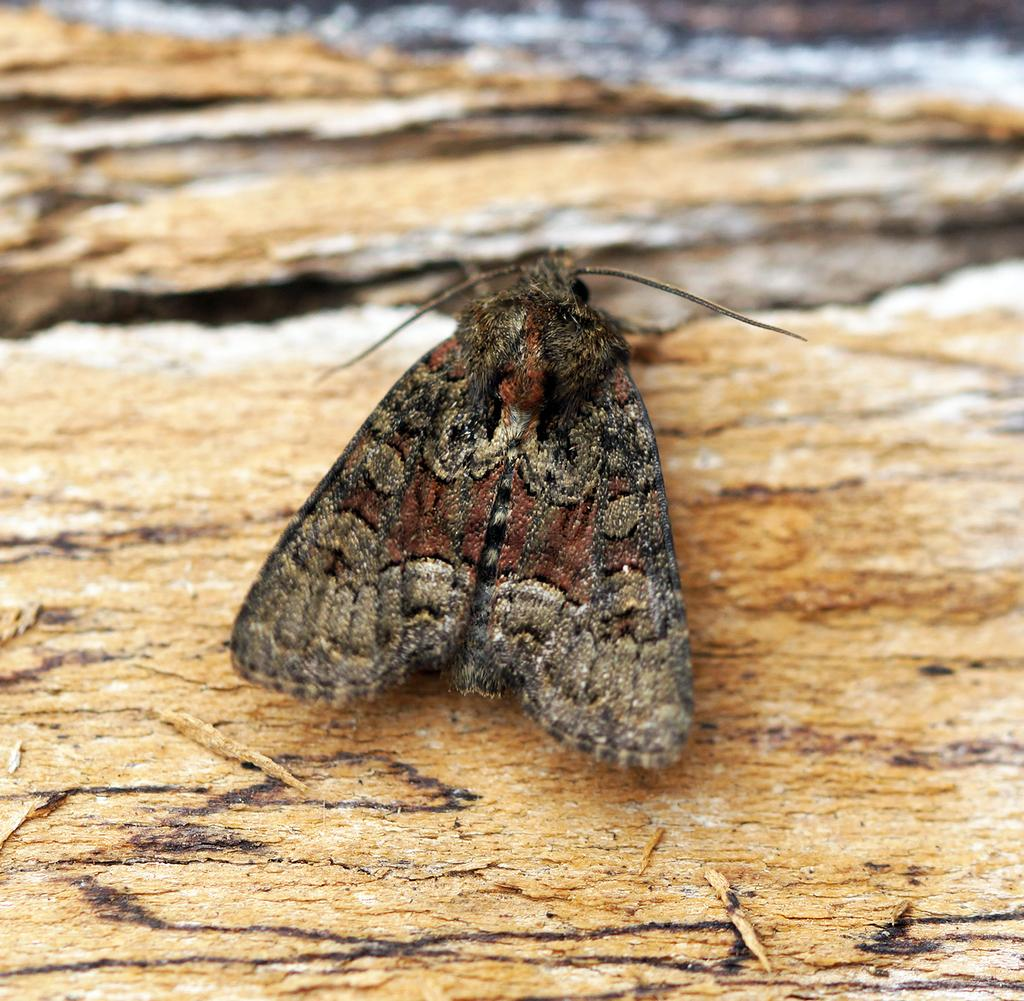What type of creature can be seen in the image? There is a butterfly in the image. What material is the surface that the butterfly is on? There is a wooden surface in the image. Can you describe the top part of the image? The top part of the image is blurred. What type of trail does the butterfly leave behind on the wooden surface? There is no trail left by the butterfly on the wooden surface in the image. 